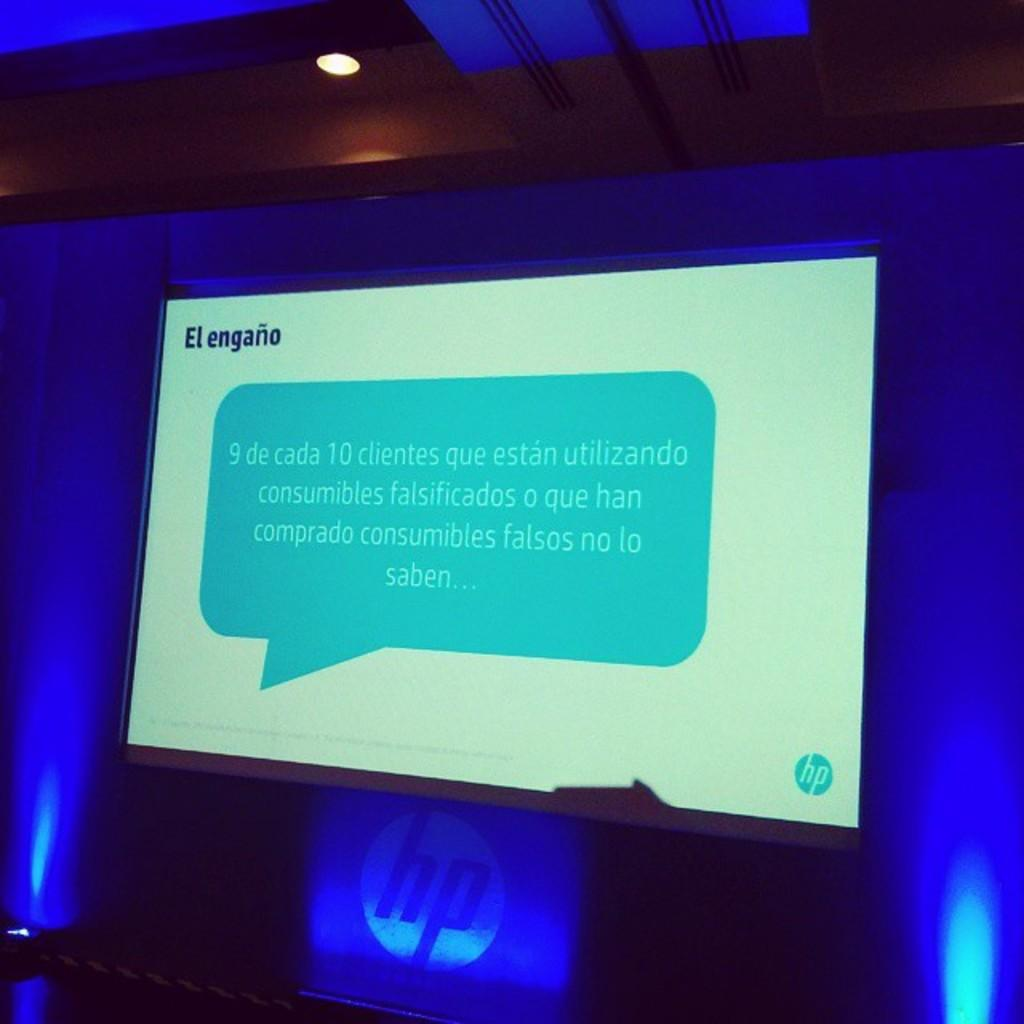<image>
Write a terse but informative summary of the picture. An HP event has a slide on the projector that says El engano. 